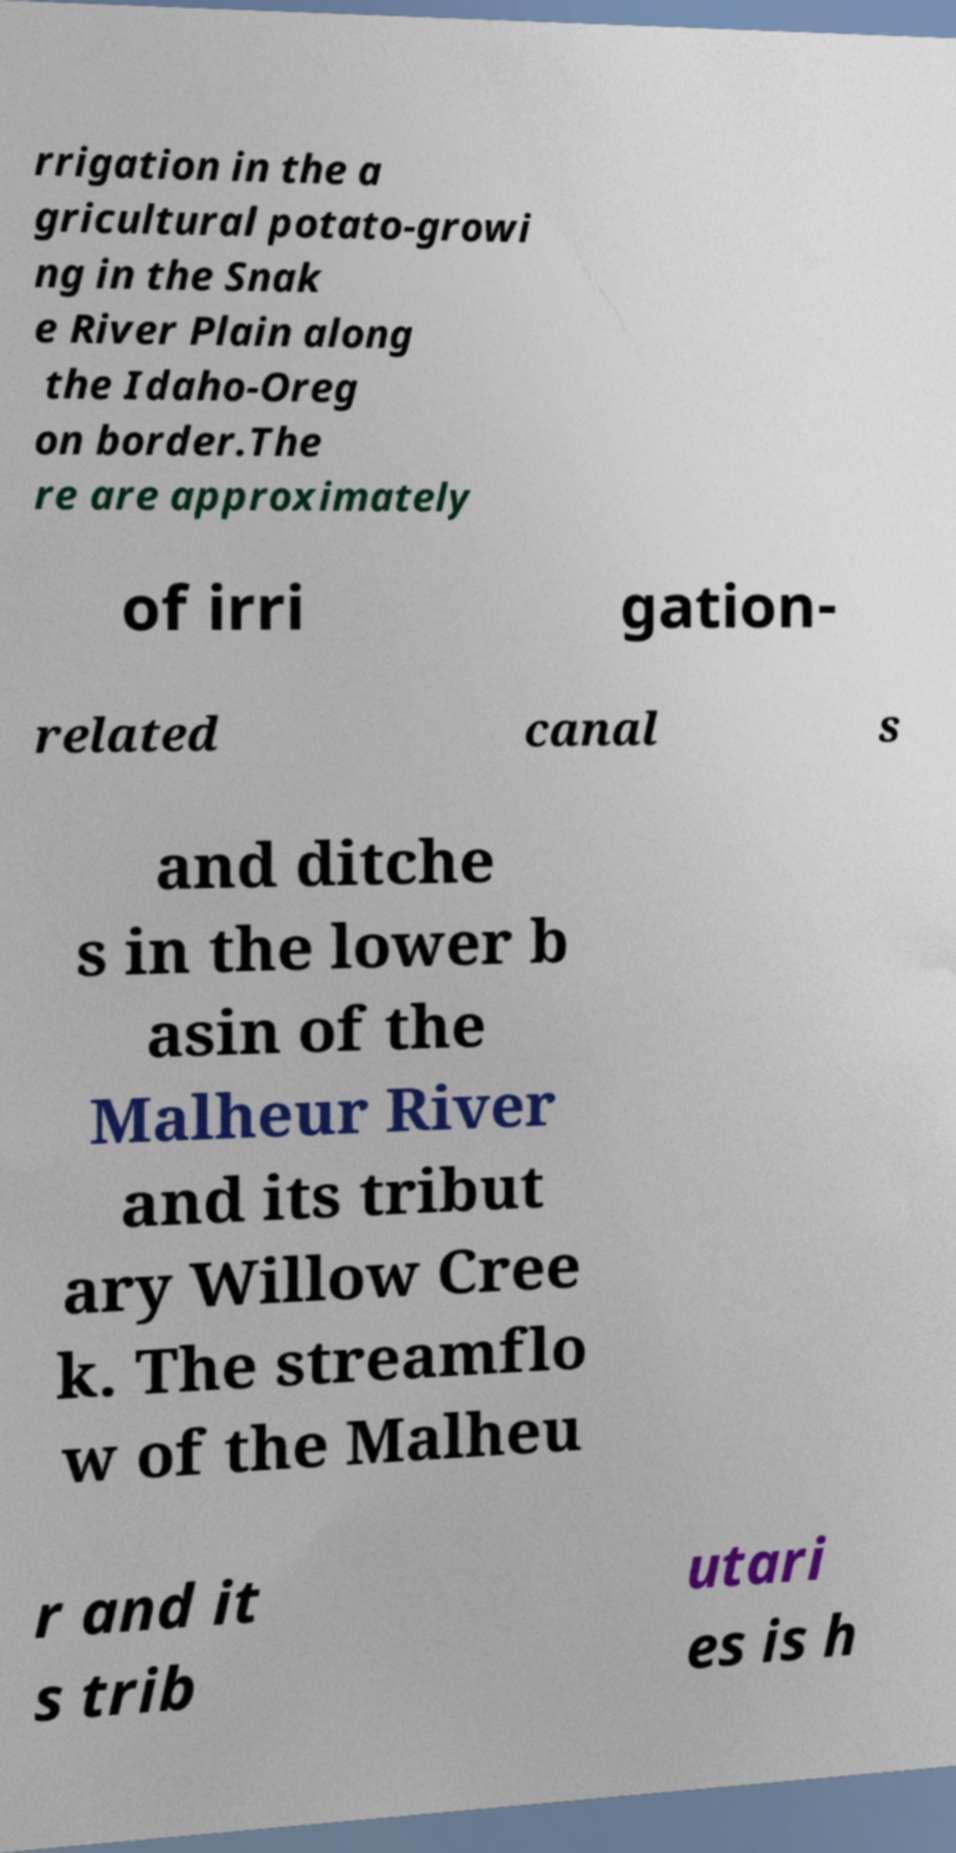There's text embedded in this image that I need extracted. Can you transcribe it verbatim? rrigation in the a gricultural potato-growi ng in the Snak e River Plain along the Idaho-Oreg on border.The re are approximately of irri gation- related canal s and ditche s in the lower b asin of the Malheur River and its tribut ary Willow Cree k. The streamflo w of the Malheu r and it s trib utari es is h 